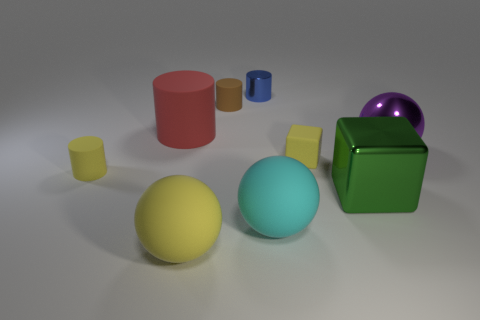Subtract all metallic spheres. How many spheres are left? 2 Subtract all blue cylinders. How many cylinders are left? 3 Subtract 1 cylinders. How many cylinders are left? 3 Subtract all cubes. How many objects are left? 7 Add 6 small yellow matte cylinders. How many small yellow matte cylinders are left? 7 Add 5 large yellow metallic cylinders. How many large yellow metallic cylinders exist? 5 Add 1 purple metal balls. How many objects exist? 10 Subtract 1 yellow blocks. How many objects are left? 8 Subtract all gray cylinders. Subtract all gray cubes. How many cylinders are left? 4 Subtract all brown blocks. How many brown cylinders are left? 1 